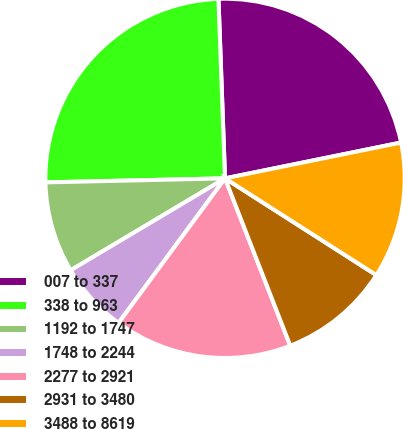Convert chart. <chart><loc_0><loc_0><loc_500><loc_500><pie_chart><fcel>007 to 337<fcel>338 to 963<fcel>1192 to 1747<fcel>1748 to 2244<fcel>2277 to 2921<fcel>2931 to 3480<fcel>3488 to 8619<nl><fcel>22.39%<fcel>24.78%<fcel>8.19%<fcel>6.35%<fcel>16.02%<fcel>10.03%<fcel>12.25%<nl></chart> 